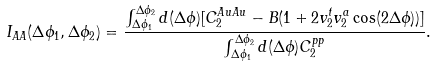Convert formula to latex. <formula><loc_0><loc_0><loc_500><loc_500>I _ { A A } ( \Delta \phi _ { 1 } , \Delta \phi _ { 2 } ) = \frac { \int _ { \Delta \phi _ { 1 } } ^ { \Delta \phi _ { 2 } } d ( \Delta \phi ) [ C _ { 2 } ^ { A u A u } - B ( 1 + 2 v _ { 2 } ^ { t } v _ { 2 } ^ { a } \cos ( 2 \Delta \phi ) ) ] } { \int _ { \Delta \phi _ { 1 } } ^ { \Delta \phi _ { 2 } } d ( \Delta \phi ) C _ { 2 } ^ { p p } } .</formula> 